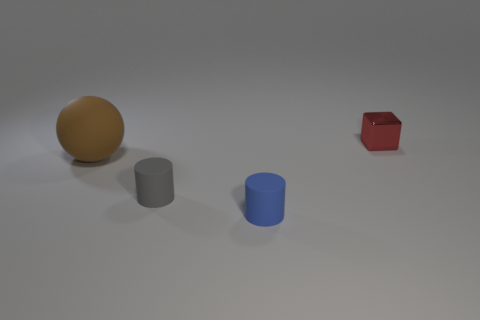Add 4 small red metal blocks. How many objects exist? 8 Subtract all balls. How many objects are left? 3 Add 3 tiny matte objects. How many tiny matte objects exist? 5 Subtract 0 purple cubes. How many objects are left? 4 Subtract all red rubber things. Subtract all big objects. How many objects are left? 3 Add 3 tiny metallic cubes. How many tiny metallic cubes are left? 4 